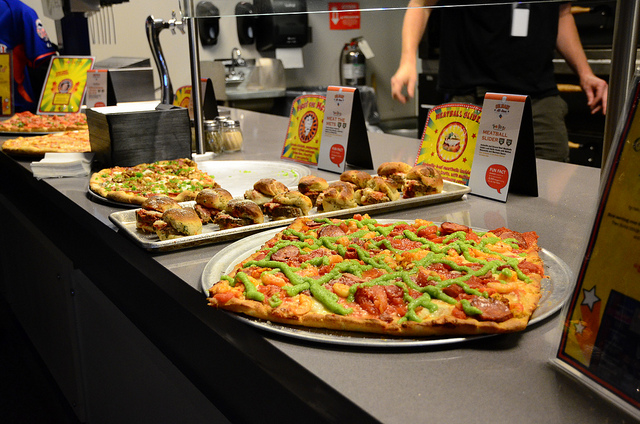<image>What hand signal is this man giving? I am not sure what hand signal the man is giving. It could be 'peace', 'done', 'okay', 'hot' or 'wonderful'. What hand signal is this man giving? I don't know what hand signal the man is giving. It is not clear in the given information. 